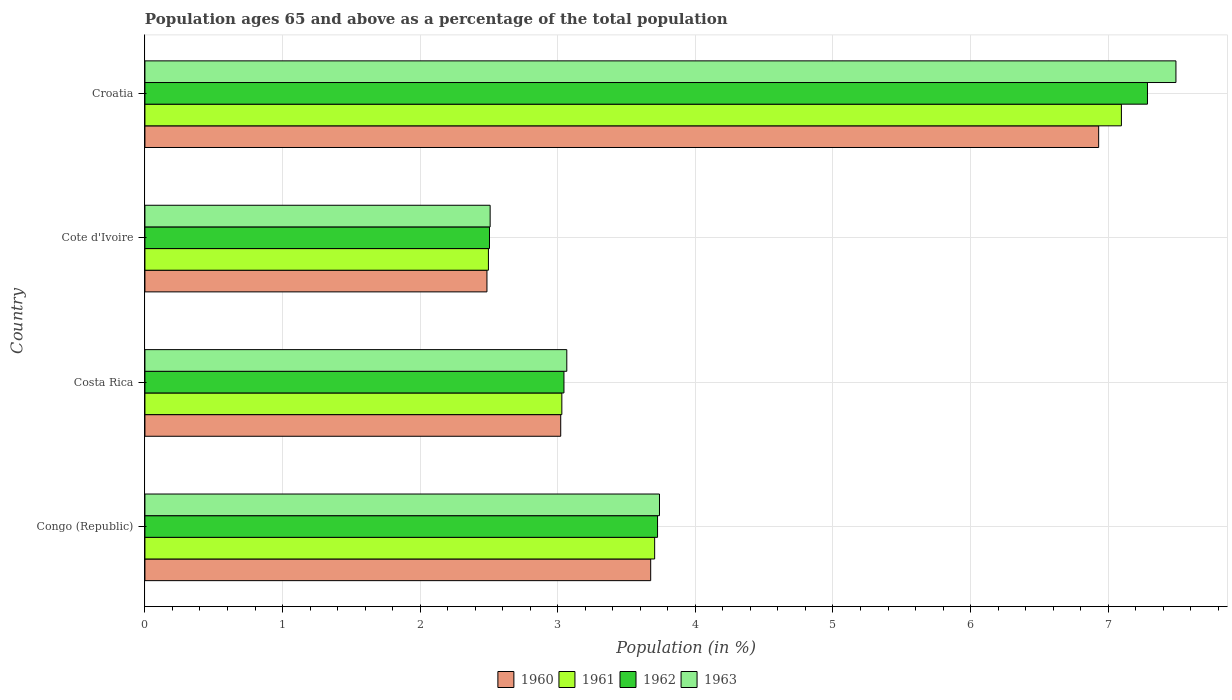How many groups of bars are there?
Offer a very short reply. 4. Are the number of bars on each tick of the Y-axis equal?
Offer a very short reply. Yes. How many bars are there on the 2nd tick from the bottom?
Keep it short and to the point. 4. What is the percentage of the population ages 65 and above in 1960 in Congo (Republic)?
Offer a terse response. 3.68. Across all countries, what is the maximum percentage of the population ages 65 and above in 1963?
Ensure brevity in your answer.  7.49. Across all countries, what is the minimum percentage of the population ages 65 and above in 1960?
Make the answer very short. 2.49. In which country was the percentage of the population ages 65 and above in 1963 maximum?
Your answer should be compact. Croatia. In which country was the percentage of the population ages 65 and above in 1962 minimum?
Your answer should be very brief. Cote d'Ivoire. What is the total percentage of the population ages 65 and above in 1961 in the graph?
Provide a succinct answer. 16.33. What is the difference between the percentage of the population ages 65 and above in 1963 in Cote d'Ivoire and that in Croatia?
Provide a succinct answer. -4.98. What is the difference between the percentage of the population ages 65 and above in 1962 in Croatia and the percentage of the population ages 65 and above in 1960 in Costa Rica?
Your response must be concise. 4.26. What is the average percentage of the population ages 65 and above in 1962 per country?
Offer a very short reply. 4.14. What is the difference between the percentage of the population ages 65 and above in 1962 and percentage of the population ages 65 and above in 1960 in Cote d'Ivoire?
Offer a terse response. 0.02. In how many countries, is the percentage of the population ages 65 and above in 1963 greater than 2.4 ?
Keep it short and to the point. 4. What is the ratio of the percentage of the population ages 65 and above in 1961 in Cote d'Ivoire to that in Croatia?
Provide a succinct answer. 0.35. Is the percentage of the population ages 65 and above in 1961 in Costa Rica less than that in Croatia?
Your answer should be compact. Yes. What is the difference between the highest and the second highest percentage of the population ages 65 and above in 1963?
Offer a very short reply. 3.75. What is the difference between the highest and the lowest percentage of the population ages 65 and above in 1961?
Keep it short and to the point. 4.6. What does the 4th bar from the top in Congo (Republic) represents?
Offer a very short reply. 1960. What does the 2nd bar from the bottom in Congo (Republic) represents?
Your answer should be very brief. 1961. Is it the case that in every country, the sum of the percentage of the population ages 65 and above in 1963 and percentage of the population ages 65 and above in 1962 is greater than the percentage of the population ages 65 and above in 1960?
Keep it short and to the point. Yes. Are all the bars in the graph horizontal?
Your answer should be very brief. Yes. How many countries are there in the graph?
Your response must be concise. 4. Are the values on the major ticks of X-axis written in scientific E-notation?
Your response must be concise. No. Does the graph contain any zero values?
Give a very brief answer. No. Where does the legend appear in the graph?
Offer a terse response. Bottom center. How are the legend labels stacked?
Provide a short and direct response. Horizontal. What is the title of the graph?
Ensure brevity in your answer.  Population ages 65 and above as a percentage of the total population. Does "2004" appear as one of the legend labels in the graph?
Your answer should be compact. No. What is the label or title of the X-axis?
Ensure brevity in your answer.  Population (in %). What is the Population (in %) in 1960 in Congo (Republic)?
Provide a short and direct response. 3.68. What is the Population (in %) in 1961 in Congo (Republic)?
Offer a terse response. 3.7. What is the Population (in %) of 1962 in Congo (Republic)?
Provide a short and direct response. 3.73. What is the Population (in %) in 1963 in Congo (Republic)?
Give a very brief answer. 3.74. What is the Population (in %) in 1960 in Costa Rica?
Your answer should be compact. 3.02. What is the Population (in %) in 1961 in Costa Rica?
Keep it short and to the point. 3.03. What is the Population (in %) of 1962 in Costa Rica?
Provide a short and direct response. 3.05. What is the Population (in %) of 1963 in Costa Rica?
Provide a short and direct response. 3.07. What is the Population (in %) in 1960 in Cote d'Ivoire?
Ensure brevity in your answer.  2.49. What is the Population (in %) in 1961 in Cote d'Ivoire?
Offer a very short reply. 2.5. What is the Population (in %) of 1962 in Cote d'Ivoire?
Your answer should be very brief. 2.5. What is the Population (in %) of 1963 in Cote d'Ivoire?
Offer a very short reply. 2.51. What is the Population (in %) of 1960 in Croatia?
Keep it short and to the point. 6.93. What is the Population (in %) in 1961 in Croatia?
Provide a succinct answer. 7.1. What is the Population (in %) in 1962 in Croatia?
Offer a very short reply. 7.29. What is the Population (in %) in 1963 in Croatia?
Provide a short and direct response. 7.49. Across all countries, what is the maximum Population (in %) of 1960?
Your answer should be compact. 6.93. Across all countries, what is the maximum Population (in %) of 1961?
Offer a terse response. 7.1. Across all countries, what is the maximum Population (in %) of 1962?
Offer a terse response. 7.29. Across all countries, what is the maximum Population (in %) in 1963?
Your answer should be compact. 7.49. Across all countries, what is the minimum Population (in %) of 1960?
Offer a terse response. 2.49. Across all countries, what is the minimum Population (in %) of 1961?
Offer a very short reply. 2.5. Across all countries, what is the minimum Population (in %) of 1962?
Provide a succinct answer. 2.5. Across all countries, what is the minimum Population (in %) of 1963?
Keep it short and to the point. 2.51. What is the total Population (in %) in 1960 in the graph?
Offer a terse response. 16.11. What is the total Population (in %) of 1961 in the graph?
Ensure brevity in your answer.  16.33. What is the total Population (in %) in 1962 in the graph?
Make the answer very short. 16.56. What is the total Population (in %) in 1963 in the graph?
Keep it short and to the point. 16.81. What is the difference between the Population (in %) of 1960 in Congo (Republic) and that in Costa Rica?
Make the answer very short. 0.65. What is the difference between the Population (in %) in 1961 in Congo (Republic) and that in Costa Rica?
Provide a short and direct response. 0.67. What is the difference between the Population (in %) in 1962 in Congo (Republic) and that in Costa Rica?
Ensure brevity in your answer.  0.68. What is the difference between the Population (in %) in 1963 in Congo (Republic) and that in Costa Rica?
Your answer should be compact. 0.67. What is the difference between the Population (in %) of 1960 in Congo (Republic) and that in Cote d'Ivoire?
Offer a terse response. 1.19. What is the difference between the Population (in %) in 1961 in Congo (Republic) and that in Cote d'Ivoire?
Provide a short and direct response. 1.21. What is the difference between the Population (in %) of 1962 in Congo (Republic) and that in Cote d'Ivoire?
Give a very brief answer. 1.22. What is the difference between the Population (in %) in 1963 in Congo (Republic) and that in Cote d'Ivoire?
Offer a terse response. 1.23. What is the difference between the Population (in %) in 1960 in Congo (Republic) and that in Croatia?
Offer a very short reply. -3.26. What is the difference between the Population (in %) of 1961 in Congo (Republic) and that in Croatia?
Give a very brief answer. -3.39. What is the difference between the Population (in %) in 1962 in Congo (Republic) and that in Croatia?
Ensure brevity in your answer.  -3.56. What is the difference between the Population (in %) in 1963 in Congo (Republic) and that in Croatia?
Provide a succinct answer. -3.75. What is the difference between the Population (in %) in 1960 in Costa Rica and that in Cote d'Ivoire?
Your response must be concise. 0.54. What is the difference between the Population (in %) of 1961 in Costa Rica and that in Cote d'Ivoire?
Your answer should be compact. 0.53. What is the difference between the Population (in %) of 1962 in Costa Rica and that in Cote d'Ivoire?
Offer a terse response. 0.54. What is the difference between the Population (in %) of 1963 in Costa Rica and that in Cote d'Ivoire?
Ensure brevity in your answer.  0.56. What is the difference between the Population (in %) in 1960 in Costa Rica and that in Croatia?
Make the answer very short. -3.91. What is the difference between the Population (in %) of 1961 in Costa Rica and that in Croatia?
Give a very brief answer. -4.07. What is the difference between the Population (in %) in 1962 in Costa Rica and that in Croatia?
Your answer should be compact. -4.24. What is the difference between the Population (in %) in 1963 in Costa Rica and that in Croatia?
Provide a succinct answer. -4.43. What is the difference between the Population (in %) in 1960 in Cote d'Ivoire and that in Croatia?
Your response must be concise. -4.45. What is the difference between the Population (in %) in 1961 in Cote d'Ivoire and that in Croatia?
Your response must be concise. -4.6. What is the difference between the Population (in %) in 1962 in Cote d'Ivoire and that in Croatia?
Your response must be concise. -4.78. What is the difference between the Population (in %) in 1963 in Cote d'Ivoire and that in Croatia?
Keep it short and to the point. -4.98. What is the difference between the Population (in %) in 1960 in Congo (Republic) and the Population (in %) in 1961 in Costa Rica?
Your answer should be compact. 0.65. What is the difference between the Population (in %) in 1960 in Congo (Republic) and the Population (in %) in 1962 in Costa Rica?
Make the answer very short. 0.63. What is the difference between the Population (in %) of 1960 in Congo (Republic) and the Population (in %) of 1963 in Costa Rica?
Ensure brevity in your answer.  0.61. What is the difference between the Population (in %) of 1961 in Congo (Republic) and the Population (in %) of 1962 in Costa Rica?
Your answer should be very brief. 0.66. What is the difference between the Population (in %) of 1961 in Congo (Republic) and the Population (in %) of 1963 in Costa Rica?
Keep it short and to the point. 0.64. What is the difference between the Population (in %) in 1962 in Congo (Republic) and the Population (in %) in 1963 in Costa Rica?
Ensure brevity in your answer.  0.66. What is the difference between the Population (in %) of 1960 in Congo (Republic) and the Population (in %) of 1961 in Cote d'Ivoire?
Your answer should be compact. 1.18. What is the difference between the Population (in %) in 1960 in Congo (Republic) and the Population (in %) in 1962 in Cote d'Ivoire?
Provide a short and direct response. 1.17. What is the difference between the Population (in %) of 1961 in Congo (Republic) and the Population (in %) of 1962 in Cote d'Ivoire?
Ensure brevity in your answer.  1.2. What is the difference between the Population (in %) of 1961 in Congo (Republic) and the Population (in %) of 1963 in Cote d'Ivoire?
Give a very brief answer. 1.2. What is the difference between the Population (in %) in 1962 in Congo (Republic) and the Population (in %) in 1963 in Cote d'Ivoire?
Your answer should be very brief. 1.22. What is the difference between the Population (in %) in 1960 in Congo (Republic) and the Population (in %) in 1961 in Croatia?
Offer a terse response. -3.42. What is the difference between the Population (in %) of 1960 in Congo (Republic) and the Population (in %) of 1962 in Croatia?
Keep it short and to the point. -3.61. What is the difference between the Population (in %) in 1960 in Congo (Republic) and the Population (in %) in 1963 in Croatia?
Provide a succinct answer. -3.82. What is the difference between the Population (in %) in 1961 in Congo (Republic) and the Population (in %) in 1962 in Croatia?
Provide a succinct answer. -3.58. What is the difference between the Population (in %) in 1961 in Congo (Republic) and the Population (in %) in 1963 in Croatia?
Offer a terse response. -3.79. What is the difference between the Population (in %) in 1962 in Congo (Republic) and the Population (in %) in 1963 in Croatia?
Offer a terse response. -3.77. What is the difference between the Population (in %) in 1960 in Costa Rica and the Population (in %) in 1961 in Cote d'Ivoire?
Your response must be concise. 0.53. What is the difference between the Population (in %) of 1960 in Costa Rica and the Population (in %) of 1962 in Cote d'Ivoire?
Offer a terse response. 0.52. What is the difference between the Population (in %) in 1960 in Costa Rica and the Population (in %) in 1963 in Cote d'Ivoire?
Offer a very short reply. 0.51. What is the difference between the Population (in %) in 1961 in Costa Rica and the Population (in %) in 1962 in Cote d'Ivoire?
Keep it short and to the point. 0.53. What is the difference between the Population (in %) in 1961 in Costa Rica and the Population (in %) in 1963 in Cote d'Ivoire?
Make the answer very short. 0.52. What is the difference between the Population (in %) of 1962 in Costa Rica and the Population (in %) of 1963 in Cote d'Ivoire?
Your answer should be compact. 0.54. What is the difference between the Population (in %) in 1960 in Costa Rica and the Population (in %) in 1961 in Croatia?
Make the answer very short. -4.07. What is the difference between the Population (in %) in 1960 in Costa Rica and the Population (in %) in 1962 in Croatia?
Your answer should be very brief. -4.26. What is the difference between the Population (in %) of 1960 in Costa Rica and the Population (in %) of 1963 in Croatia?
Offer a terse response. -4.47. What is the difference between the Population (in %) of 1961 in Costa Rica and the Population (in %) of 1962 in Croatia?
Provide a succinct answer. -4.26. What is the difference between the Population (in %) in 1961 in Costa Rica and the Population (in %) in 1963 in Croatia?
Your response must be concise. -4.46. What is the difference between the Population (in %) in 1962 in Costa Rica and the Population (in %) in 1963 in Croatia?
Your answer should be compact. -4.45. What is the difference between the Population (in %) in 1960 in Cote d'Ivoire and the Population (in %) in 1961 in Croatia?
Offer a terse response. -4.61. What is the difference between the Population (in %) in 1960 in Cote d'Ivoire and the Population (in %) in 1962 in Croatia?
Give a very brief answer. -4.8. What is the difference between the Population (in %) of 1960 in Cote d'Ivoire and the Population (in %) of 1963 in Croatia?
Provide a succinct answer. -5.01. What is the difference between the Population (in %) in 1961 in Cote d'Ivoire and the Population (in %) in 1962 in Croatia?
Provide a succinct answer. -4.79. What is the difference between the Population (in %) of 1961 in Cote d'Ivoire and the Population (in %) of 1963 in Croatia?
Make the answer very short. -5. What is the difference between the Population (in %) of 1962 in Cote d'Ivoire and the Population (in %) of 1963 in Croatia?
Offer a very short reply. -4.99. What is the average Population (in %) in 1960 per country?
Give a very brief answer. 4.03. What is the average Population (in %) of 1961 per country?
Your response must be concise. 4.08. What is the average Population (in %) of 1962 per country?
Offer a terse response. 4.14. What is the average Population (in %) in 1963 per country?
Your answer should be compact. 4.2. What is the difference between the Population (in %) in 1960 and Population (in %) in 1961 in Congo (Republic)?
Offer a very short reply. -0.03. What is the difference between the Population (in %) of 1960 and Population (in %) of 1962 in Congo (Republic)?
Offer a very short reply. -0.05. What is the difference between the Population (in %) in 1960 and Population (in %) in 1963 in Congo (Republic)?
Make the answer very short. -0.06. What is the difference between the Population (in %) of 1961 and Population (in %) of 1962 in Congo (Republic)?
Keep it short and to the point. -0.02. What is the difference between the Population (in %) of 1961 and Population (in %) of 1963 in Congo (Republic)?
Provide a short and direct response. -0.04. What is the difference between the Population (in %) in 1962 and Population (in %) in 1963 in Congo (Republic)?
Ensure brevity in your answer.  -0.01. What is the difference between the Population (in %) of 1960 and Population (in %) of 1961 in Costa Rica?
Offer a very short reply. -0.01. What is the difference between the Population (in %) in 1960 and Population (in %) in 1962 in Costa Rica?
Give a very brief answer. -0.02. What is the difference between the Population (in %) in 1960 and Population (in %) in 1963 in Costa Rica?
Ensure brevity in your answer.  -0.04. What is the difference between the Population (in %) in 1961 and Population (in %) in 1962 in Costa Rica?
Your answer should be very brief. -0.02. What is the difference between the Population (in %) of 1961 and Population (in %) of 1963 in Costa Rica?
Ensure brevity in your answer.  -0.04. What is the difference between the Population (in %) of 1962 and Population (in %) of 1963 in Costa Rica?
Provide a succinct answer. -0.02. What is the difference between the Population (in %) in 1960 and Population (in %) in 1961 in Cote d'Ivoire?
Offer a very short reply. -0.01. What is the difference between the Population (in %) of 1960 and Population (in %) of 1962 in Cote d'Ivoire?
Your response must be concise. -0.02. What is the difference between the Population (in %) in 1960 and Population (in %) in 1963 in Cote d'Ivoire?
Make the answer very short. -0.02. What is the difference between the Population (in %) in 1961 and Population (in %) in 1962 in Cote d'Ivoire?
Offer a very short reply. -0.01. What is the difference between the Population (in %) of 1961 and Population (in %) of 1963 in Cote d'Ivoire?
Keep it short and to the point. -0.01. What is the difference between the Population (in %) in 1962 and Population (in %) in 1963 in Cote d'Ivoire?
Offer a very short reply. -0. What is the difference between the Population (in %) in 1960 and Population (in %) in 1961 in Croatia?
Your answer should be very brief. -0.17. What is the difference between the Population (in %) in 1960 and Population (in %) in 1962 in Croatia?
Give a very brief answer. -0.35. What is the difference between the Population (in %) in 1960 and Population (in %) in 1963 in Croatia?
Your response must be concise. -0.56. What is the difference between the Population (in %) of 1961 and Population (in %) of 1962 in Croatia?
Your response must be concise. -0.19. What is the difference between the Population (in %) of 1961 and Population (in %) of 1963 in Croatia?
Offer a terse response. -0.4. What is the difference between the Population (in %) of 1962 and Population (in %) of 1963 in Croatia?
Offer a very short reply. -0.21. What is the ratio of the Population (in %) in 1960 in Congo (Republic) to that in Costa Rica?
Your answer should be very brief. 1.22. What is the ratio of the Population (in %) of 1961 in Congo (Republic) to that in Costa Rica?
Provide a short and direct response. 1.22. What is the ratio of the Population (in %) of 1962 in Congo (Republic) to that in Costa Rica?
Ensure brevity in your answer.  1.22. What is the ratio of the Population (in %) in 1963 in Congo (Republic) to that in Costa Rica?
Provide a short and direct response. 1.22. What is the ratio of the Population (in %) in 1960 in Congo (Republic) to that in Cote d'Ivoire?
Your answer should be compact. 1.48. What is the ratio of the Population (in %) in 1961 in Congo (Republic) to that in Cote d'Ivoire?
Your answer should be compact. 1.48. What is the ratio of the Population (in %) in 1962 in Congo (Republic) to that in Cote d'Ivoire?
Offer a terse response. 1.49. What is the ratio of the Population (in %) of 1963 in Congo (Republic) to that in Cote d'Ivoire?
Your answer should be compact. 1.49. What is the ratio of the Population (in %) in 1960 in Congo (Republic) to that in Croatia?
Offer a terse response. 0.53. What is the ratio of the Population (in %) of 1961 in Congo (Republic) to that in Croatia?
Your answer should be compact. 0.52. What is the ratio of the Population (in %) in 1962 in Congo (Republic) to that in Croatia?
Keep it short and to the point. 0.51. What is the ratio of the Population (in %) in 1963 in Congo (Republic) to that in Croatia?
Give a very brief answer. 0.5. What is the ratio of the Population (in %) of 1960 in Costa Rica to that in Cote d'Ivoire?
Give a very brief answer. 1.22. What is the ratio of the Population (in %) of 1961 in Costa Rica to that in Cote d'Ivoire?
Offer a terse response. 1.21. What is the ratio of the Population (in %) of 1962 in Costa Rica to that in Cote d'Ivoire?
Give a very brief answer. 1.22. What is the ratio of the Population (in %) in 1963 in Costa Rica to that in Cote d'Ivoire?
Provide a short and direct response. 1.22. What is the ratio of the Population (in %) in 1960 in Costa Rica to that in Croatia?
Give a very brief answer. 0.44. What is the ratio of the Population (in %) in 1961 in Costa Rica to that in Croatia?
Give a very brief answer. 0.43. What is the ratio of the Population (in %) of 1962 in Costa Rica to that in Croatia?
Offer a very short reply. 0.42. What is the ratio of the Population (in %) of 1963 in Costa Rica to that in Croatia?
Your answer should be very brief. 0.41. What is the ratio of the Population (in %) in 1960 in Cote d'Ivoire to that in Croatia?
Your answer should be very brief. 0.36. What is the ratio of the Population (in %) of 1961 in Cote d'Ivoire to that in Croatia?
Give a very brief answer. 0.35. What is the ratio of the Population (in %) of 1962 in Cote d'Ivoire to that in Croatia?
Offer a terse response. 0.34. What is the ratio of the Population (in %) of 1963 in Cote d'Ivoire to that in Croatia?
Keep it short and to the point. 0.33. What is the difference between the highest and the second highest Population (in %) in 1960?
Provide a short and direct response. 3.26. What is the difference between the highest and the second highest Population (in %) of 1961?
Make the answer very short. 3.39. What is the difference between the highest and the second highest Population (in %) in 1962?
Ensure brevity in your answer.  3.56. What is the difference between the highest and the second highest Population (in %) of 1963?
Ensure brevity in your answer.  3.75. What is the difference between the highest and the lowest Population (in %) in 1960?
Ensure brevity in your answer.  4.45. What is the difference between the highest and the lowest Population (in %) of 1961?
Make the answer very short. 4.6. What is the difference between the highest and the lowest Population (in %) in 1962?
Your response must be concise. 4.78. What is the difference between the highest and the lowest Population (in %) of 1963?
Your answer should be compact. 4.98. 